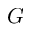Convert formula to latex. <formula><loc_0><loc_0><loc_500><loc_500>G</formula> 